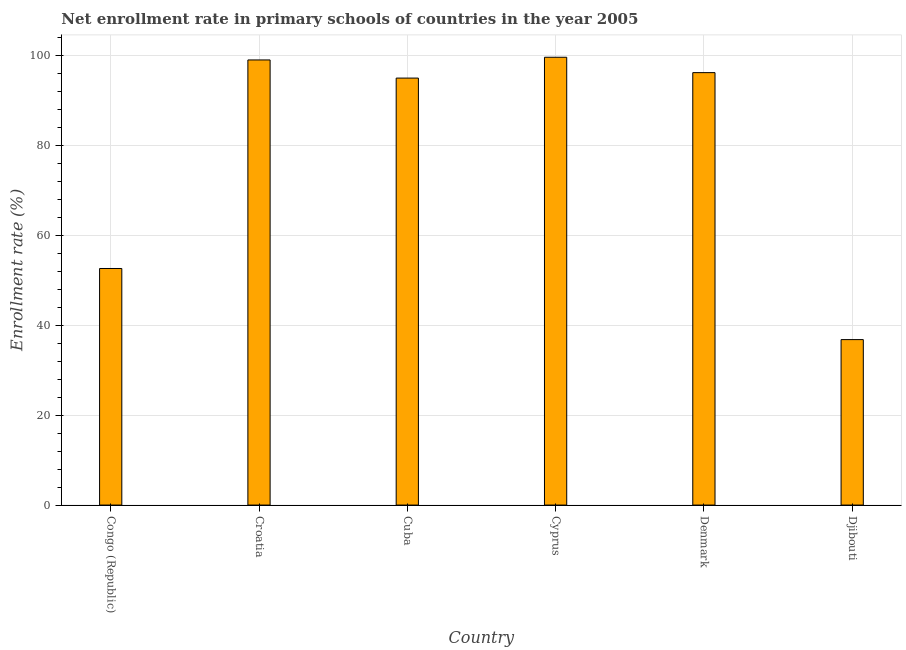Does the graph contain any zero values?
Provide a succinct answer. No. Does the graph contain grids?
Provide a succinct answer. Yes. What is the title of the graph?
Offer a very short reply. Net enrollment rate in primary schools of countries in the year 2005. What is the label or title of the Y-axis?
Offer a very short reply. Enrollment rate (%). What is the net enrollment rate in primary schools in Croatia?
Offer a terse response. 99.07. Across all countries, what is the maximum net enrollment rate in primary schools?
Your answer should be compact. 99.66. Across all countries, what is the minimum net enrollment rate in primary schools?
Offer a very short reply. 36.83. In which country was the net enrollment rate in primary schools maximum?
Ensure brevity in your answer.  Cyprus. In which country was the net enrollment rate in primary schools minimum?
Your response must be concise. Djibouti. What is the sum of the net enrollment rate in primary schools?
Make the answer very short. 479.47. What is the difference between the net enrollment rate in primary schools in Denmark and Djibouti?
Make the answer very short. 59.41. What is the average net enrollment rate in primary schools per country?
Your answer should be very brief. 79.91. What is the median net enrollment rate in primary schools?
Make the answer very short. 95.63. In how many countries, is the net enrollment rate in primary schools greater than 64 %?
Your response must be concise. 4. What is the ratio of the net enrollment rate in primary schools in Cyprus to that in Djibouti?
Ensure brevity in your answer.  2.71. Is the net enrollment rate in primary schools in Croatia less than that in Cyprus?
Make the answer very short. Yes. Is the difference between the net enrollment rate in primary schools in Congo (Republic) and Cuba greater than the difference between any two countries?
Your response must be concise. No. What is the difference between the highest and the second highest net enrollment rate in primary schools?
Provide a succinct answer. 0.6. What is the difference between the highest and the lowest net enrollment rate in primary schools?
Give a very brief answer. 62.84. How many countries are there in the graph?
Provide a succinct answer. 6. What is the difference between two consecutive major ticks on the Y-axis?
Offer a very short reply. 20. Are the values on the major ticks of Y-axis written in scientific E-notation?
Offer a very short reply. No. What is the Enrollment rate (%) in Congo (Republic)?
Offer a very short reply. 52.65. What is the Enrollment rate (%) of Croatia?
Keep it short and to the point. 99.07. What is the Enrollment rate (%) of Cuba?
Ensure brevity in your answer.  95.03. What is the Enrollment rate (%) in Cyprus?
Your answer should be very brief. 99.66. What is the Enrollment rate (%) of Denmark?
Your response must be concise. 96.24. What is the Enrollment rate (%) in Djibouti?
Make the answer very short. 36.83. What is the difference between the Enrollment rate (%) in Congo (Republic) and Croatia?
Ensure brevity in your answer.  -46.41. What is the difference between the Enrollment rate (%) in Congo (Republic) and Cuba?
Provide a short and direct response. -42.38. What is the difference between the Enrollment rate (%) in Congo (Republic) and Cyprus?
Your answer should be very brief. -47.01. What is the difference between the Enrollment rate (%) in Congo (Republic) and Denmark?
Your answer should be very brief. -43.59. What is the difference between the Enrollment rate (%) in Congo (Republic) and Djibouti?
Keep it short and to the point. 15.83. What is the difference between the Enrollment rate (%) in Croatia and Cuba?
Offer a terse response. 4.04. What is the difference between the Enrollment rate (%) in Croatia and Cyprus?
Ensure brevity in your answer.  -0.6. What is the difference between the Enrollment rate (%) in Croatia and Denmark?
Provide a succinct answer. 2.82. What is the difference between the Enrollment rate (%) in Croatia and Djibouti?
Provide a short and direct response. 62.24. What is the difference between the Enrollment rate (%) in Cuba and Cyprus?
Keep it short and to the point. -4.63. What is the difference between the Enrollment rate (%) in Cuba and Denmark?
Your response must be concise. -1.21. What is the difference between the Enrollment rate (%) in Cuba and Djibouti?
Ensure brevity in your answer.  58.2. What is the difference between the Enrollment rate (%) in Cyprus and Denmark?
Provide a short and direct response. 3.42. What is the difference between the Enrollment rate (%) in Cyprus and Djibouti?
Your response must be concise. 62.84. What is the difference between the Enrollment rate (%) in Denmark and Djibouti?
Give a very brief answer. 59.41. What is the ratio of the Enrollment rate (%) in Congo (Republic) to that in Croatia?
Provide a short and direct response. 0.53. What is the ratio of the Enrollment rate (%) in Congo (Republic) to that in Cuba?
Your response must be concise. 0.55. What is the ratio of the Enrollment rate (%) in Congo (Republic) to that in Cyprus?
Your answer should be very brief. 0.53. What is the ratio of the Enrollment rate (%) in Congo (Republic) to that in Denmark?
Your response must be concise. 0.55. What is the ratio of the Enrollment rate (%) in Congo (Republic) to that in Djibouti?
Offer a terse response. 1.43. What is the ratio of the Enrollment rate (%) in Croatia to that in Cuba?
Make the answer very short. 1.04. What is the ratio of the Enrollment rate (%) in Croatia to that in Cyprus?
Offer a terse response. 0.99. What is the ratio of the Enrollment rate (%) in Croatia to that in Denmark?
Ensure brevity in your answer.  1.03. What is the ratio of the Enrollment rate (%) in Croatia to that in Djibouti?
Ensure brevity in your answer.  2.69. What is the ratio of the Enrollment rate (%) in Cuba to that in Cyprus?
Your answer should be compact. 0.95. What is the ratio of the Enrollment rate (%) in Cuba to that in Djibouti?
Your answer should be compact. 2.58. What is the ratio of the Enrollment rate (%) in Cyprus to that in Denmark?
Keep it short and to the point. 1.04. What is the ratio of the Enrollment rate (%) in Cyprus to that in Djibouti?
Provide a short and direct response. 2.71. What is the ratio of the Enrollment rate (%) in Denmark to that in Djibouti?
Offer a very short reply. 2.61. 